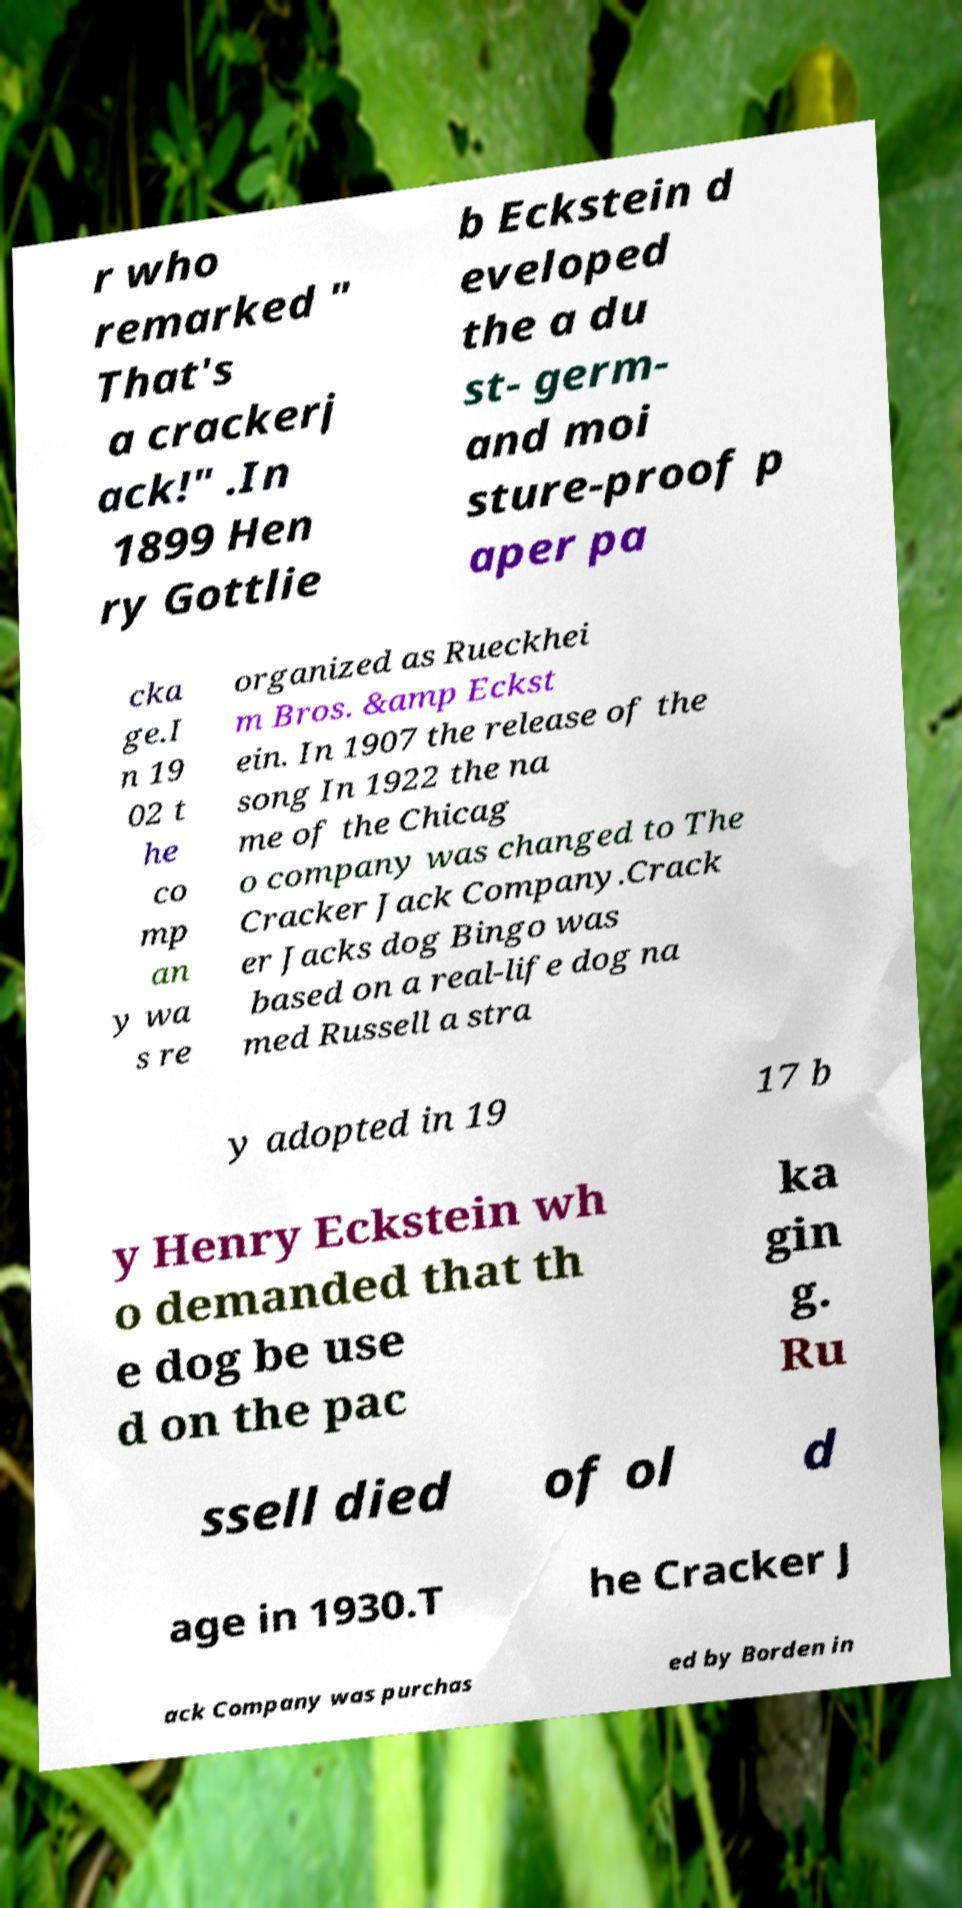Could you assist in decoding the text presented in this image and type it out clearly? r who remarked " That's a crackerj ack!" .In 1899 Hen ry Gottlie b Eckstein d eveloped the a du st- germ- and moi sture-proof p aper pa cka ge.I n 19 02 t he co mp an y wa s re organized as Rueckhei m Bros. &amp Eckst ein. In 1907 the release of the song In 1922 the na me of the Chicag o company was changed to The Cracker Jack Company.Crack er Jacks dog Bingo was based on a real-life dog na med Russell a stra y adopted in 19 17 b y Henry Eckstein wh o demanded that th e dog be use d on the pac ka gin g. Ru ssell died of ol d age in 1930.T he Cracker J ack Company was purchas ed by Borden in 